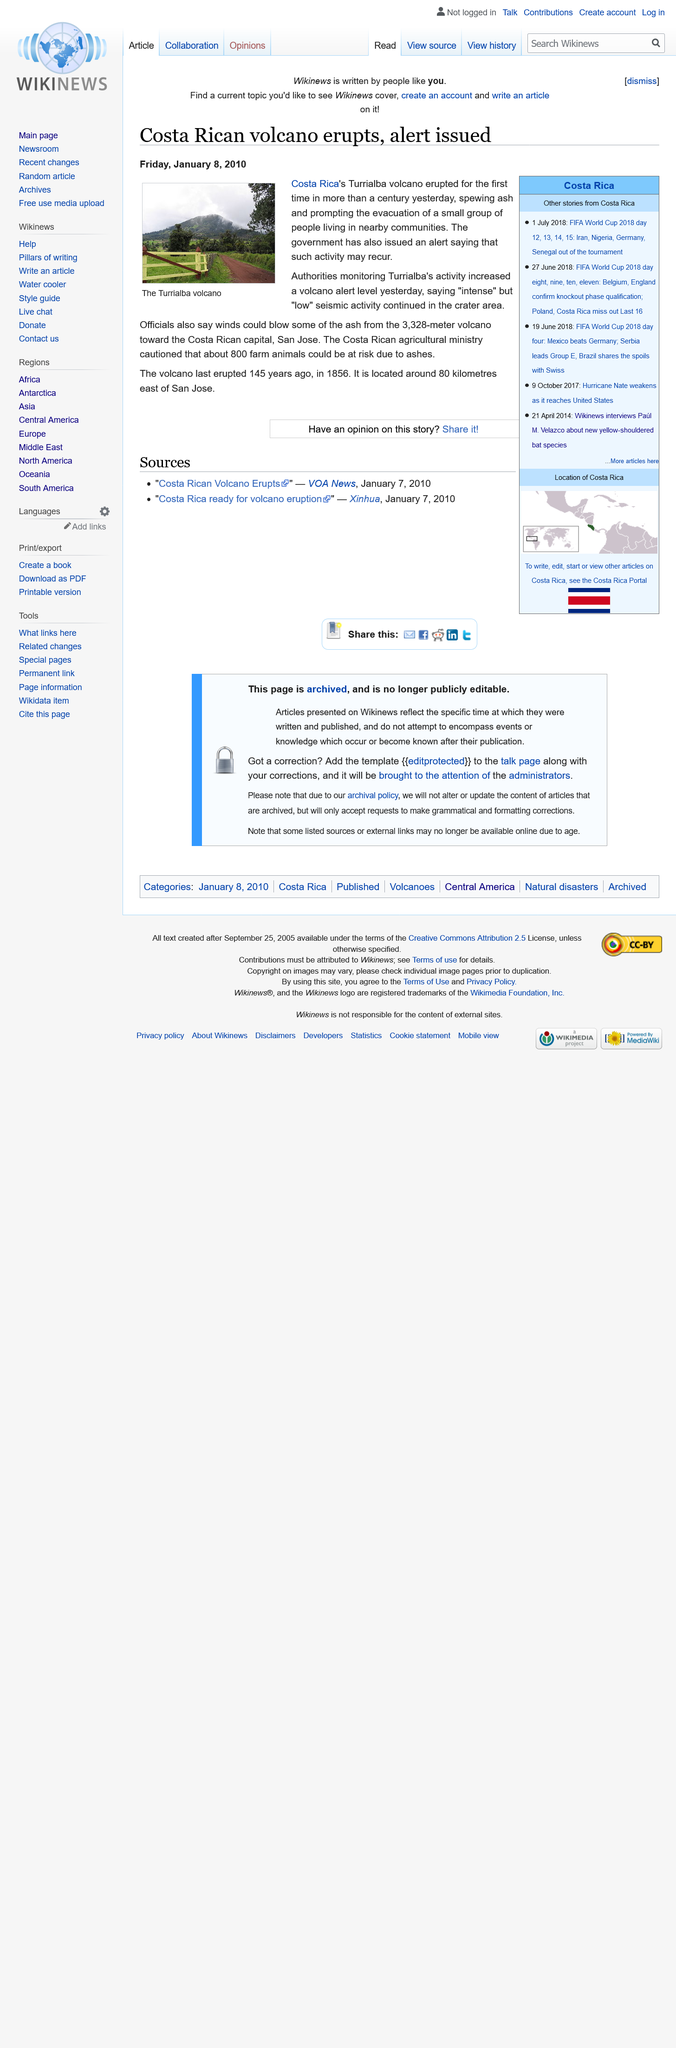Outline some significant characteristics in this image. The Costa Rican agriculture ministry warned that approximately 800 farm animals could be affected due to the presence of ash in their food supply, as a result of the eruption of the Turrialba Volcano. The volcano last erupted 145 years ago in 1856. The volcano is located approximately 80 kilometers east of San Jose, making it easily accessible for those interested in exploring this geological wonder. 